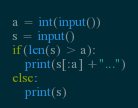<code> <loc_0><loc_0><loc_500><loc_500><_Python_>a = int(input())
s = input()
if(len(s) > a):
    print(s[:a] +"...")
else:
    print(s)</code> 